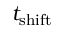Convert formula to latex. <formula><loc_0><loc_0><loc_500><loc_500>t _ { s h i f t }</formula> 